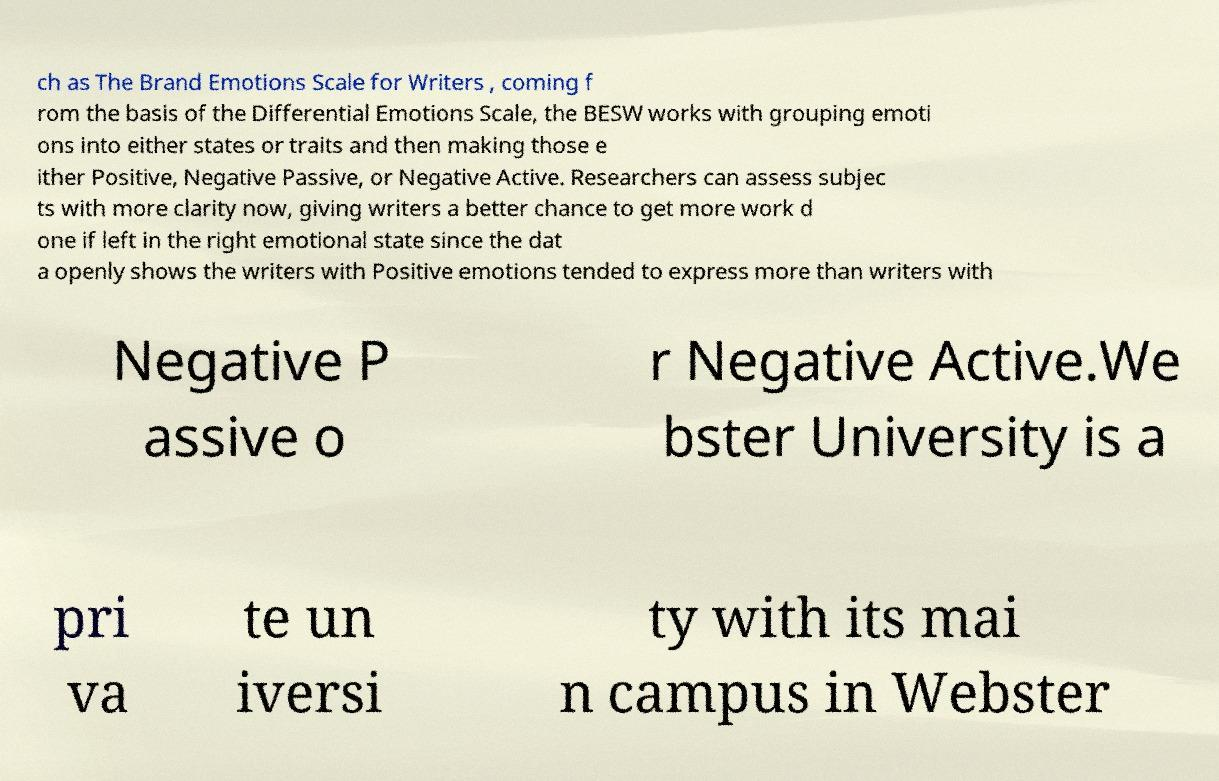There's text embedded in this image that I need extracted. Can you transcribe it verbatim? ch as The Brand Emotions Scale for Writers , coming f rom the basis of the Differential Emotions Scale, the BESW works with grouping emoti ons into either states or traits and then making those e ither Positive, Negative Passive, or Negative Active. Researchers can assess subjec ts with more clarity now, giving writers a better chance to get more work d one if left in the right emotional state since the dat a openly shows the writers with Positive emotions tended to express more than writers with Negative P assive o r Negative Active.We bster University is a pri va te un iversi ty with its mai n campus in Webster 